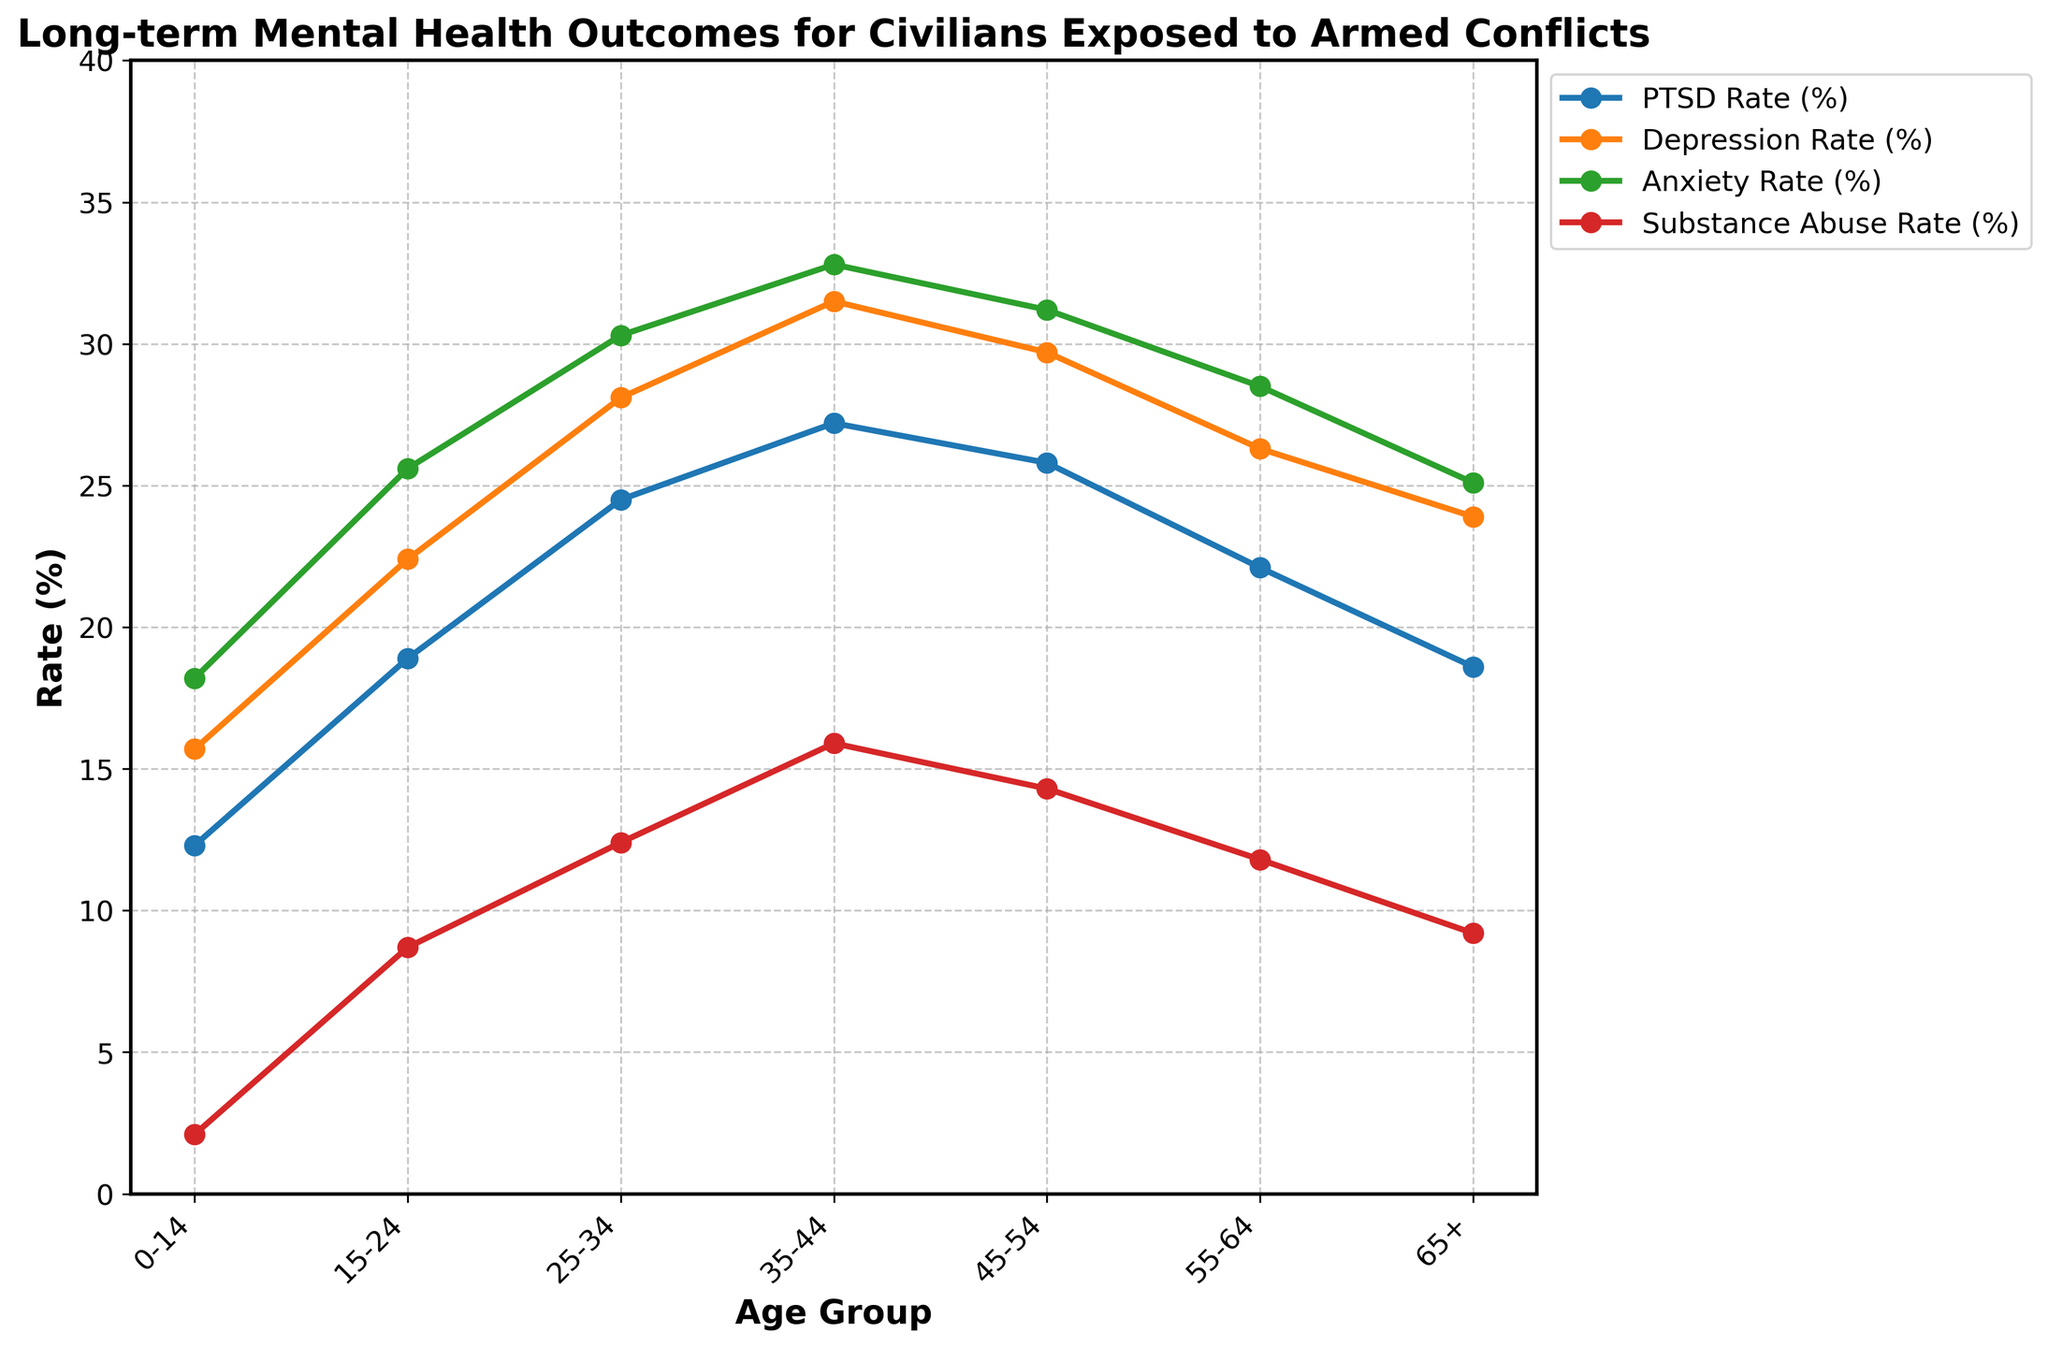What's the PTSD rate for the 0-14 age group? Locate the line in the chart labeled "PTSD Rate (%)" and find the data point corresponding to the "0-14" age group. The chart shows that the value is 12.3%.
Answer: 12.3% Which age group has the highest depression rate? Locate the line in the chart labeled "Depression Rate (%)" and identify the highest point on the y-axis. The "35-44" age group shows the highest value of 31.5%.
Answer: 35-44 How does the anxiety rate compare between the 15-24 and the 55-64 age groups? Locate the line in the chart labeled "Anxiety Rate (%)". The value for the 15-24 age group is 25.6%, while for the 55-64 age group, it is 28.5%. Comparing these, 15-24 is lower than 55-64.
Answer: 15-24 is lower What is the difference in substance abuse rates between the 35-44 and 0-14 age groups? Locate the line in the chart labeled "Substance Abuse Rate (%)". The value at 35-44 is 15.9%, and at 0-14, it is 2.1%. Subtract the smaller value from the larger: 15.9% - 2.1% = 13.8%.
Answer: 13.8% What's the average rate of PTSD across all age groups? Sum all the PTSD rate values and divide by the number of age groups. (12.3 + 18.9 + 24.5 + 27.2 + 25.8 + 22.1 + 18.6) / 7 = 21.34%.
Answer: 21.34% Which age group shows a decreasing trend in PTSD rate after 35-44? Observe the line labeled "PTSD Rate (%)" and note the values for age groups after "35-44". There is a clear decreasing trend starting from the "45-54" age group.
Answer: 45-54 What is the range of depression rates across all age groups? Identify the highest and lowest points on the line labeled "Depression Rate (%)". The highest rate is 31.5% (35-44) and the lowest is 15.7% (0-14). Calculate the range: 31.5% - 15.7% = 15.8%.
Answer: 15.8% Which mental health outcome shows the steepest increase from the 0-14 to 15-24 age groups? Compare the slope of the lines between the 0-14 and 15-24 age groups for each mental health outcome. The substance abuse rate increases from 2.1% to 8.7%, resulting in the steepest increase of 6.6%.
Answer: Substance Abuse How does the depression rate differ between the 25-34 and 65+ age groups? Locate the line labeled "Depression Rate (%)" and read the values for the 25-34 and 65+ age groups. The value for 25-34 is 28.1%, and for 65+ is 23.9%. Calculate the difference: 28.1% - 23.9% = 4.2%.
Answer: 4.2% 